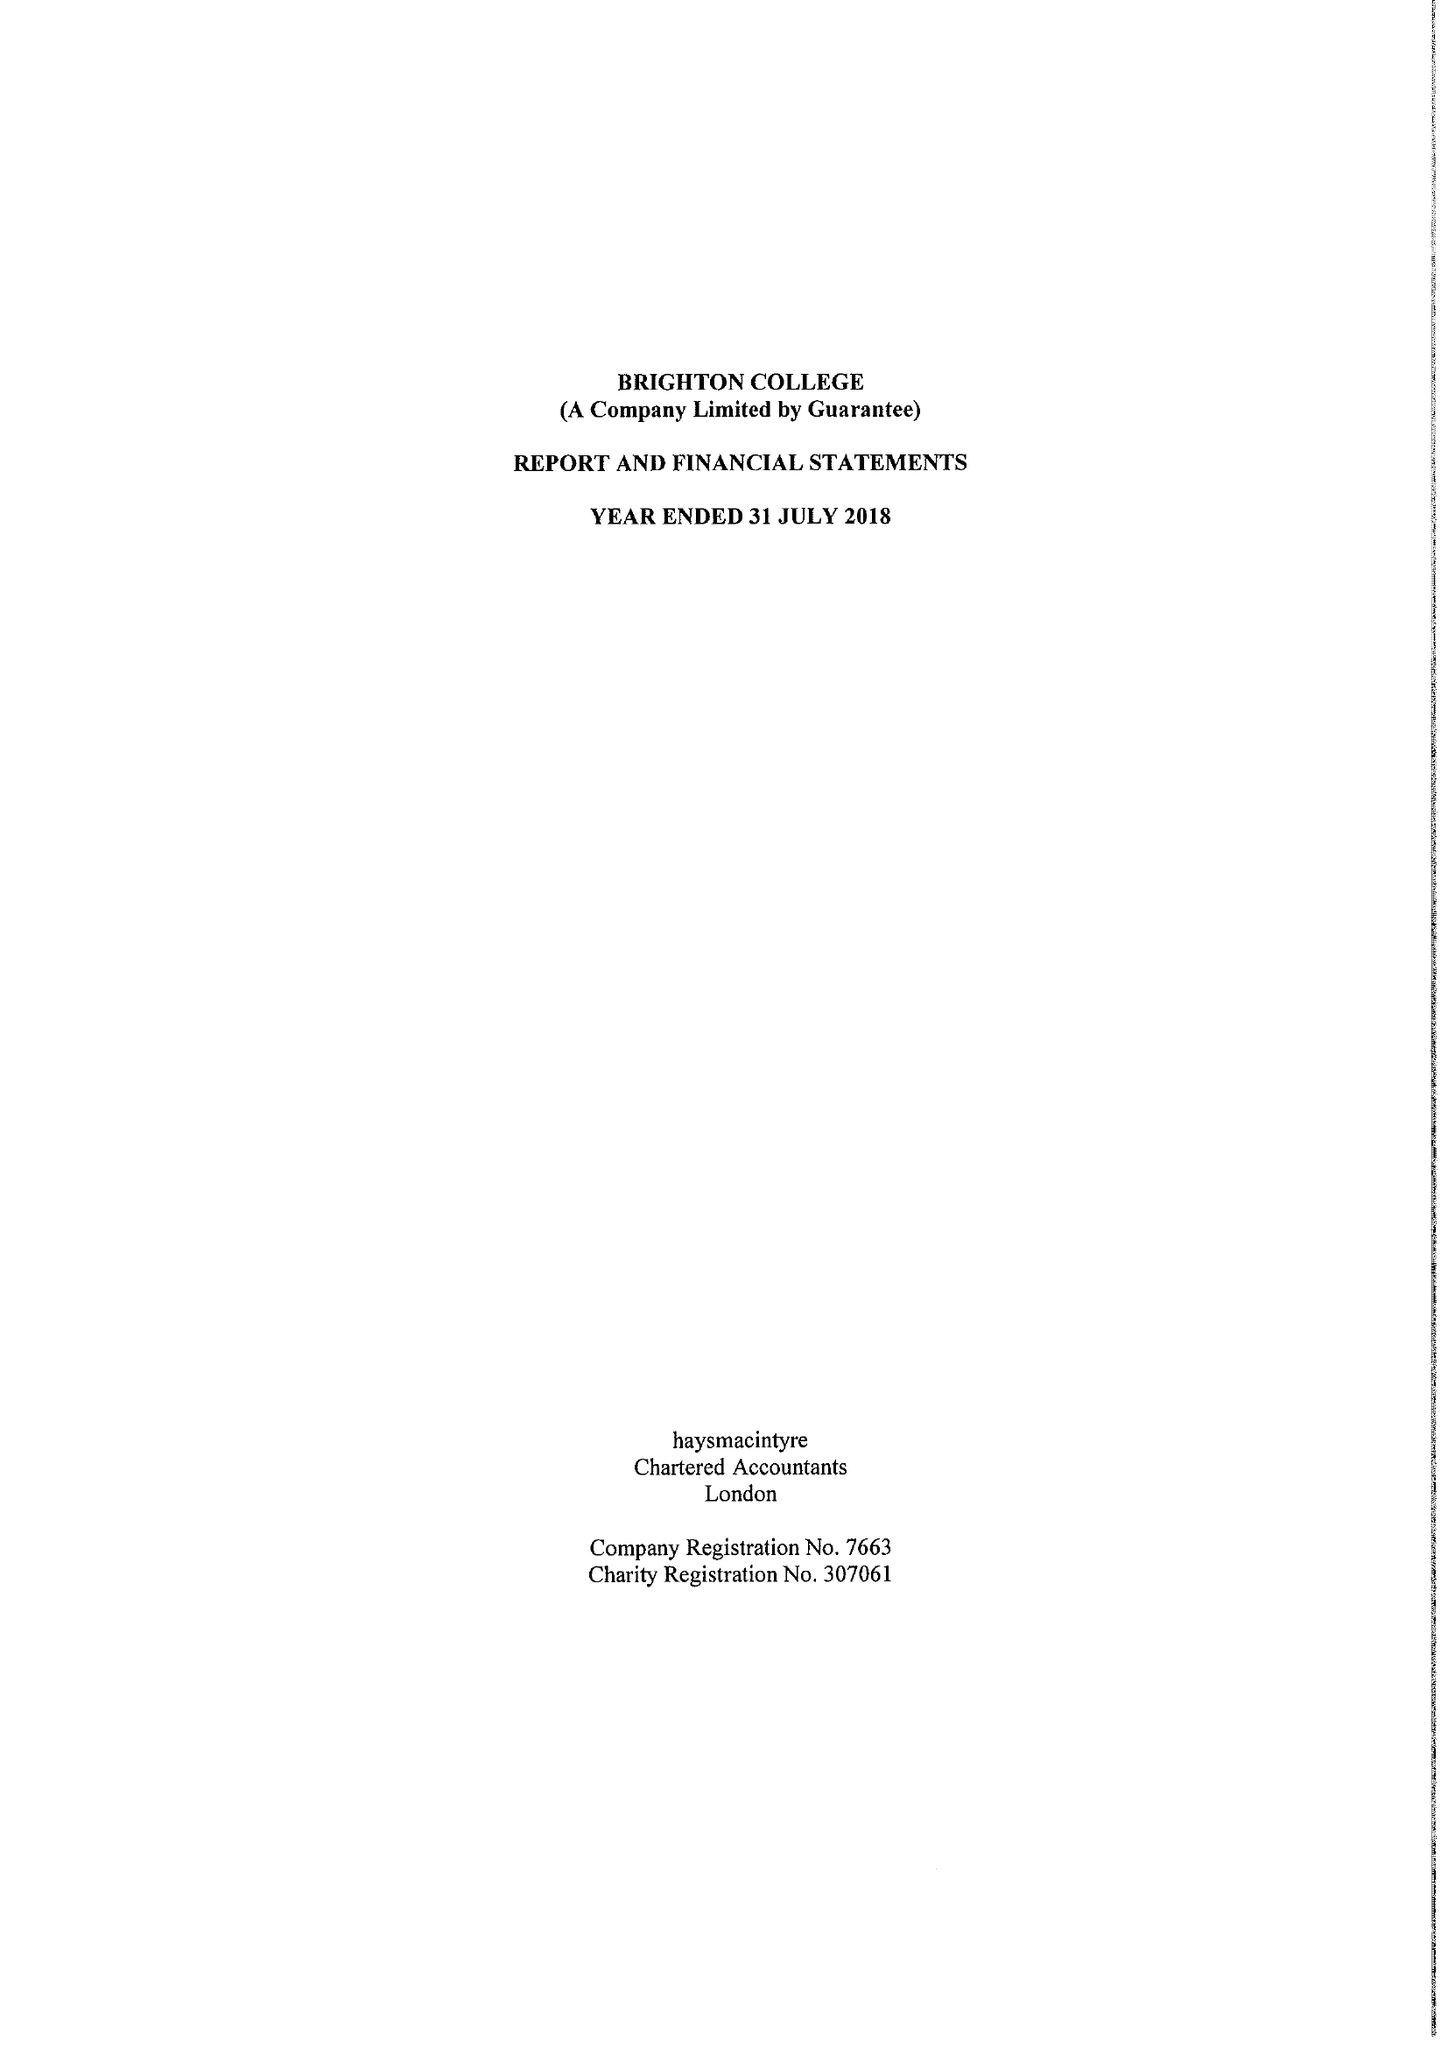What is the value for the report_date?
Answer the question using a single word or phrase. 2018-07-31 